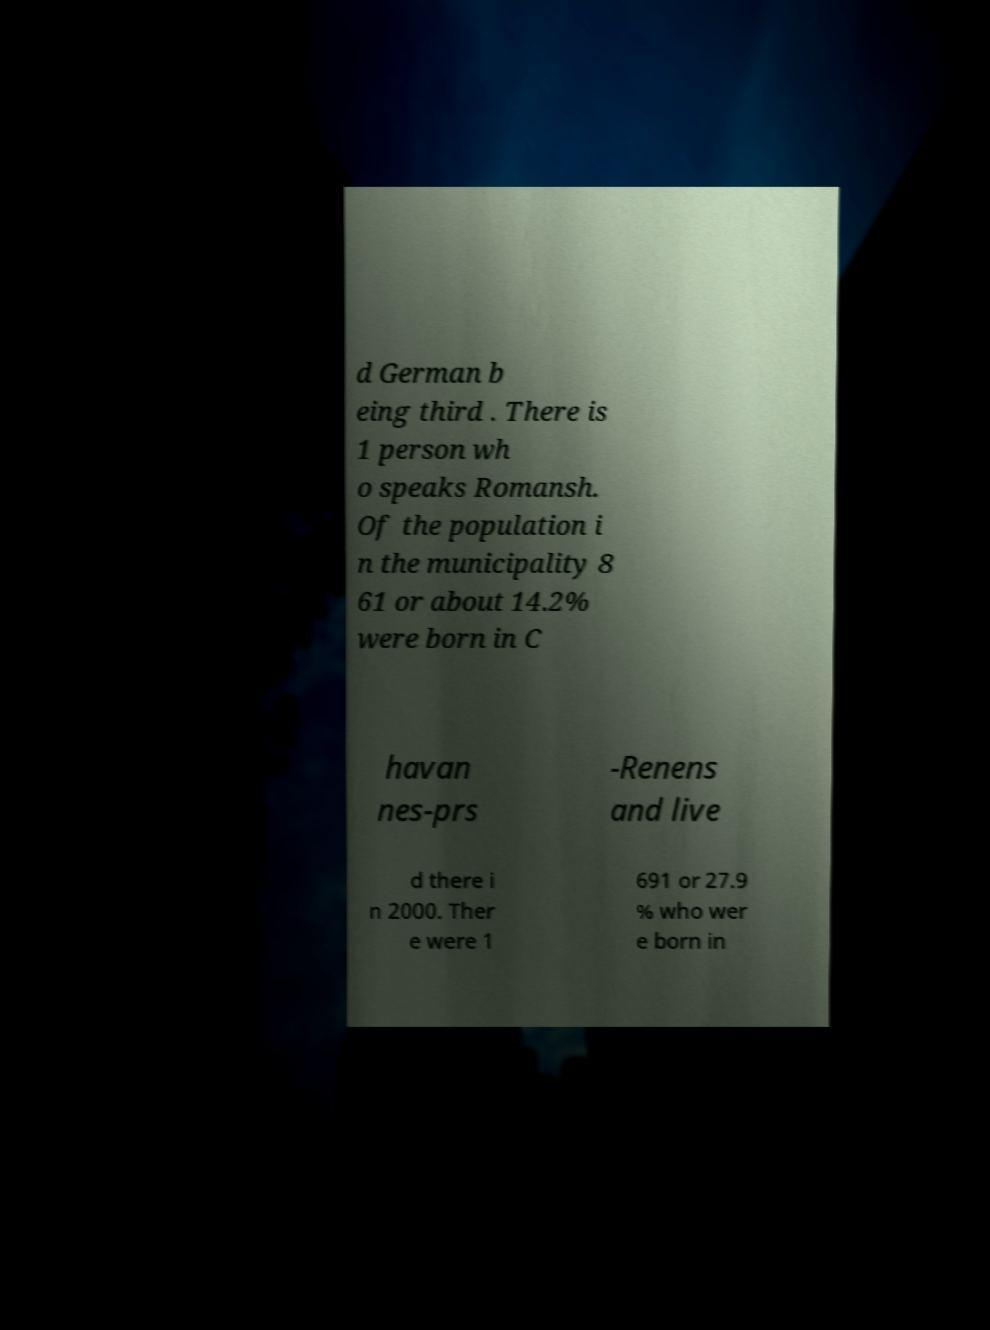There's text embedded in this image that I need extracted. Can you transcribe it verbatim? d German b eing third . There is 1 person wh o speaks Romansh. Of the population i n the municipality 8 61 or about 14.2% were born in C havan nes-prs -Renens and live d there i n 2000. Ther e were 1 691 or 27.9 % who wer e born in 